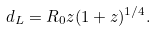Convert formula to latex. <formula><loc_0><loc_0><loc_500><loc_500>d _ { L } = R _ { 0 } z ( 1 + z ) ^ { 1 / 4 } .</formula> 